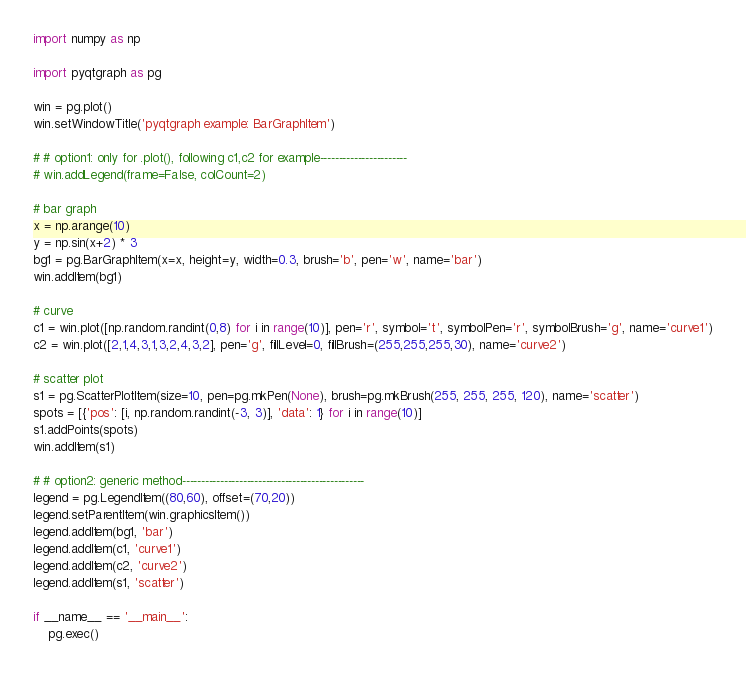<code> <loc_0><loc_0><loc_500><loc_500><_Python_>
import numpy as np

import pyqtgraph as pg

win = pg.plot()
win.setWindowTitle('pyqtgraph example: BarGraphItem')

# # option1: only for .plot(), following c1,c2 for example-----------------------
# win.addLegend(frame=False, colCount=2)

# bar graph
x = np.arange(10)
y = np.sin(x+2) * 3
bg1 = pg.BarGraphItem(x=x, height=y, width=0.3, brush='b', pen='w', name='bar')
win.addItem(bg1)

# curve
c1 = win.plot([np.random.randint(0,8) for i in range(10)], pen='r', symbol='t', symbolPen='r', symbolBrush='g', name='curve1')
c2 = win.plot([2,1,4,3,1,3,2,4,3,2], pen='g', fillLevel=0, fillBrush=(255,255,255,30), name='curve2')

# scatter plot
s1 = pg.ScatterPlotItem(size=10, pen=pg.mkPen(None), brush=pg.mkBrush(255, 255, 255, 120), name='scatter')
spots = [{'pos': [i, np.random.randint(-3, 3)], 'data': 1} for i in range(10)]
s1.addPoints(spots)
win.addItem(s1)

# # option2: generic method------------------------------------------------
legend = pg.LegendItem((80,60), offset=(70,20))
legend.setParentItem(win.graphicsItem())
legend.addItem(bg1, 'bar')
legend.addItem(c1, 'curve1')
legend.addItem(c2, 'curve2')
legend.addItem(s1, 'scatter')

if __name__ == '__main__':
    pg.exec()
</code> 